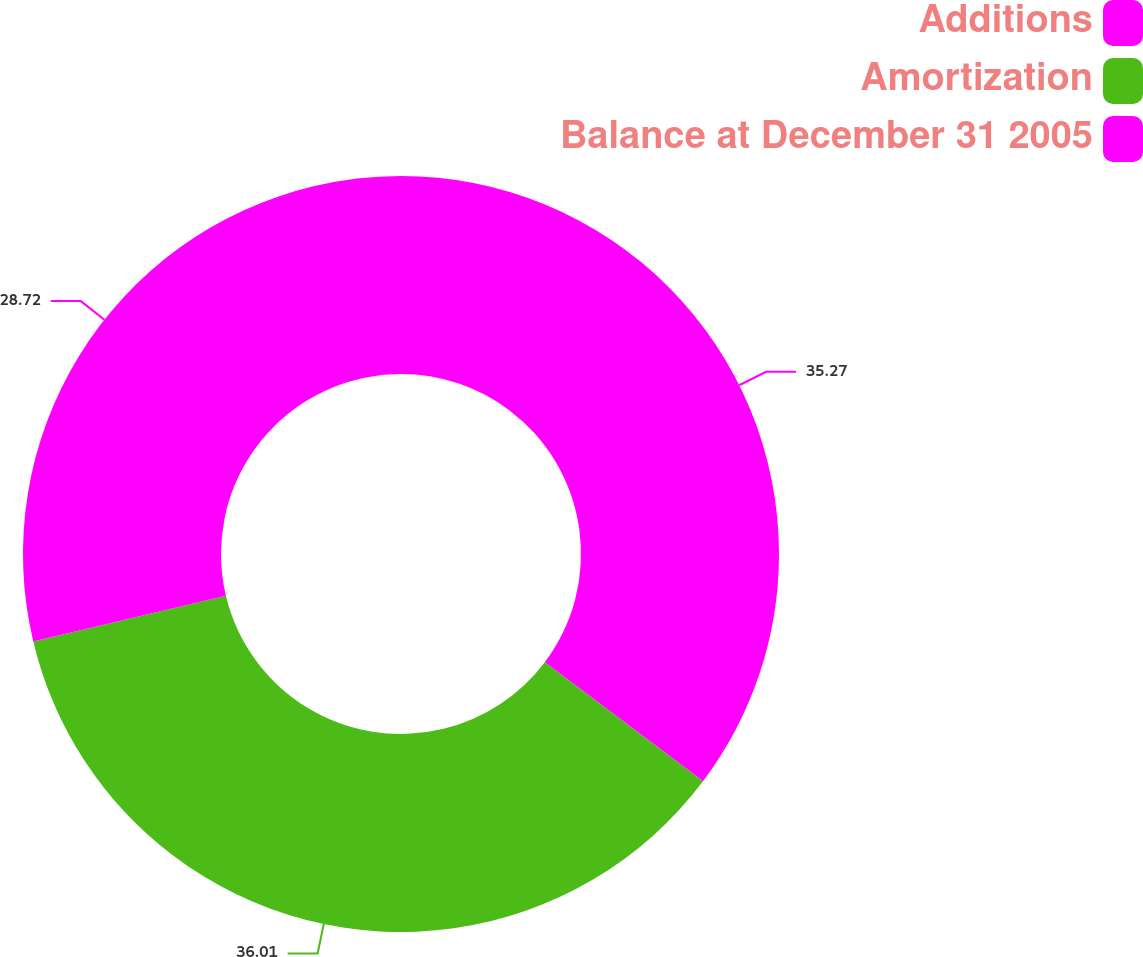Convert chart. <chart><loc_0><loc_0><loc_500><loc_500><pie_chart><fcel>Additions<fcel>Amortization<fcel>Balance at December 31 2005<nl><fcel>35.27%<fcel>36.01%<fcel>28.72%<nl></chart> 